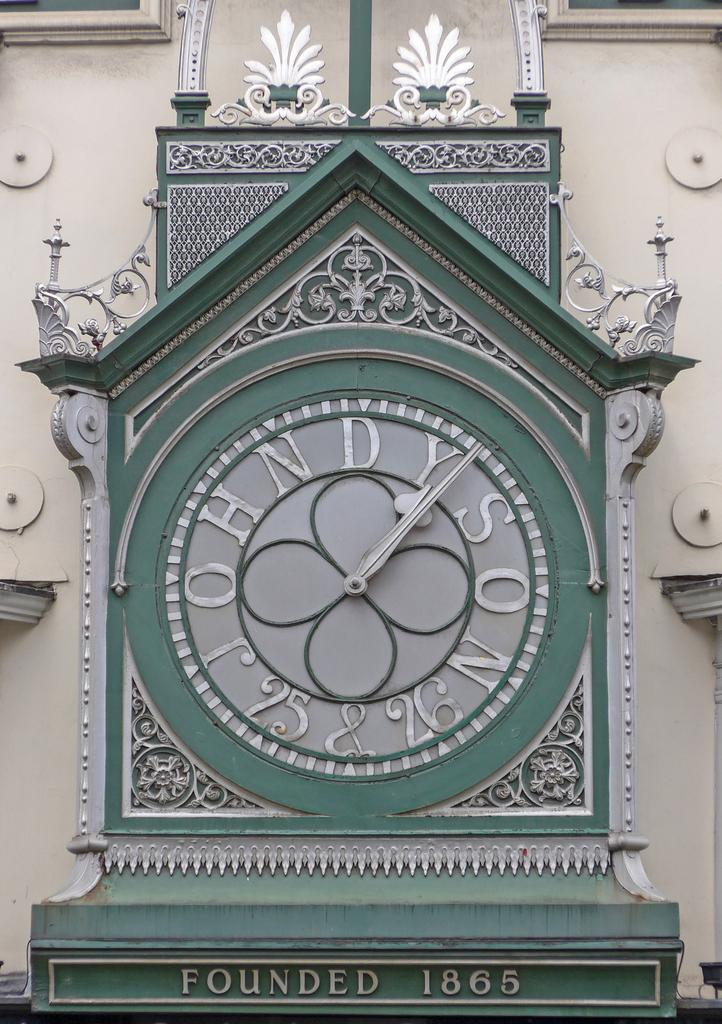Provide a one-sentence caption for the provided image. A clock says founded in 1865 under it. 